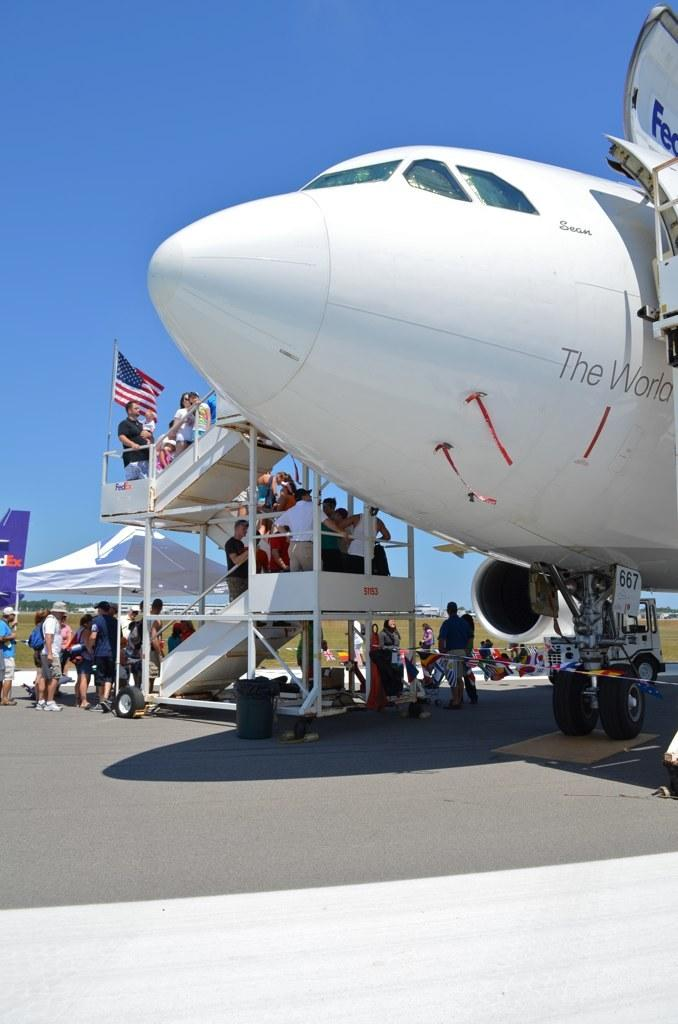What is the main subject of the image? The main subject of the image is an airplane. Where is the airplane located in the image? The airplane is placed on the road. What can be seen in the background of the image? There is a group of people, a tent, and flags in the background of the image. What is visible at the top of the image? The sky is visible at the top of the image. What type of ink can be seen dripping from the airplane in the image? There is no ink dripping from the airplane in the image. What suggestion is being made by the group of people in the background of the image? The image does not provide any information about the suggestions being made by the group of people in the background. 